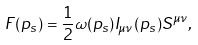Convert formula to latex. <formula><loc_0><loc_0><loc_500><loc_500>F ( p _ { s } ) = \frac { 1 } { 2 } \omega ( p _ { s } ) I _ { \mu \nu } ( p _ { s } ) S ^ { \mu \nu } ,</formula> 